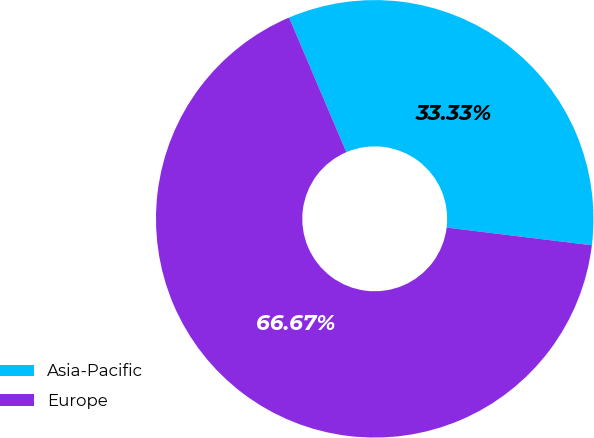Convert chart. <chart><loc_0><loc_0><loc_500><loc_500><pie_chart><fcel>Asia-Pacific<fcel>Europe<nl><fcel>33.33%<fcel>66.67%<nl></chart> 